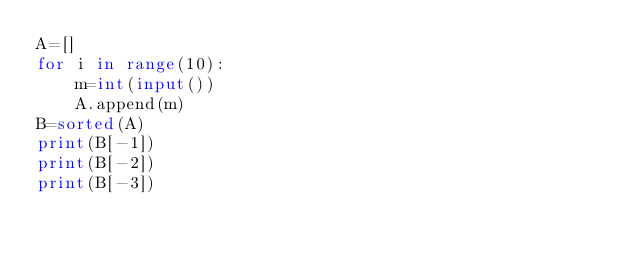Convert code to text. <code><loc_0><loc_0><loc_500><loc_500><_Python_>A=[]
for i in range(10):
    m=int(input())
    A.append(m)
B=sorted(A)
print(B[-1])
print(B[-2])
print(B[-3])
</code> 